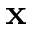<formula> <loc_0><loc_0><loc_500><loc_500>x</formula> 